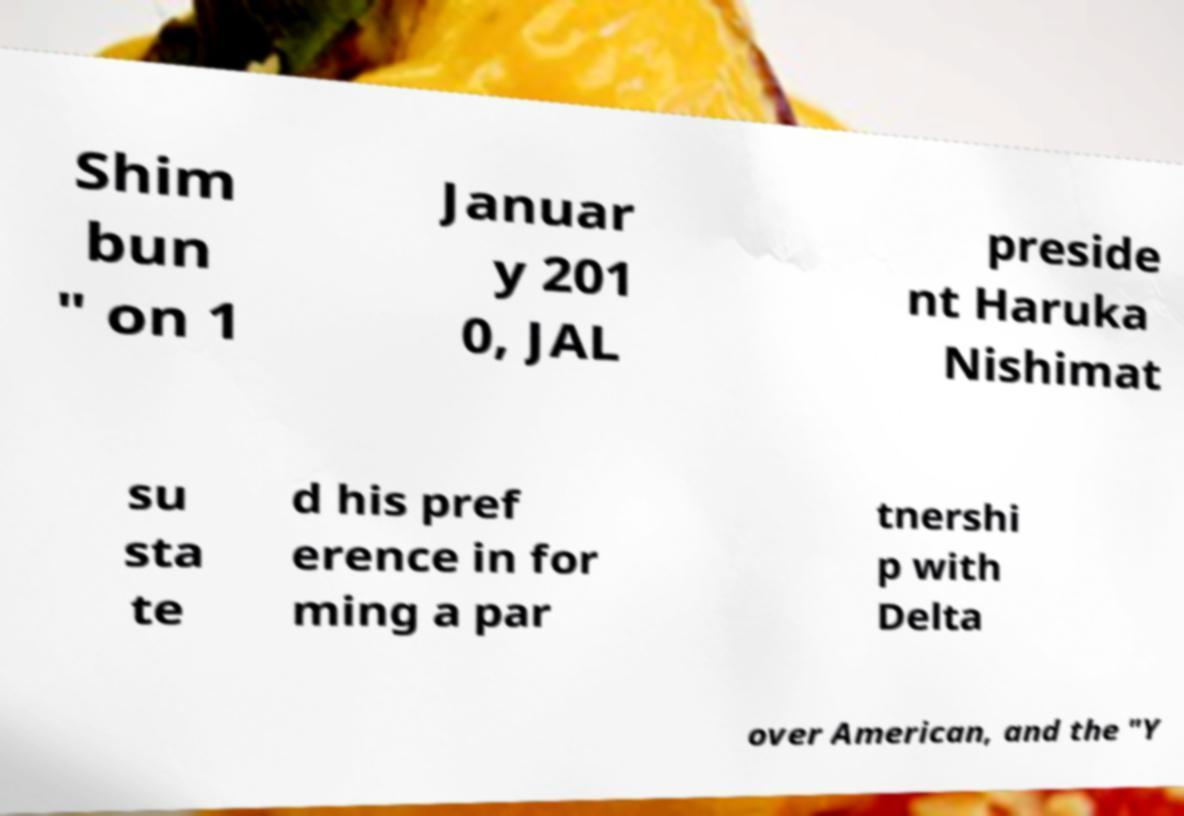Could you assist in decoding the text presented in this image and type it out clearly? Shim bun " on 1 Januar y 201 0, JAL preside nt Haruka Nishimat su sta te d his pref erence in for ming a par tnershi p with Delta over American, and the "Y 